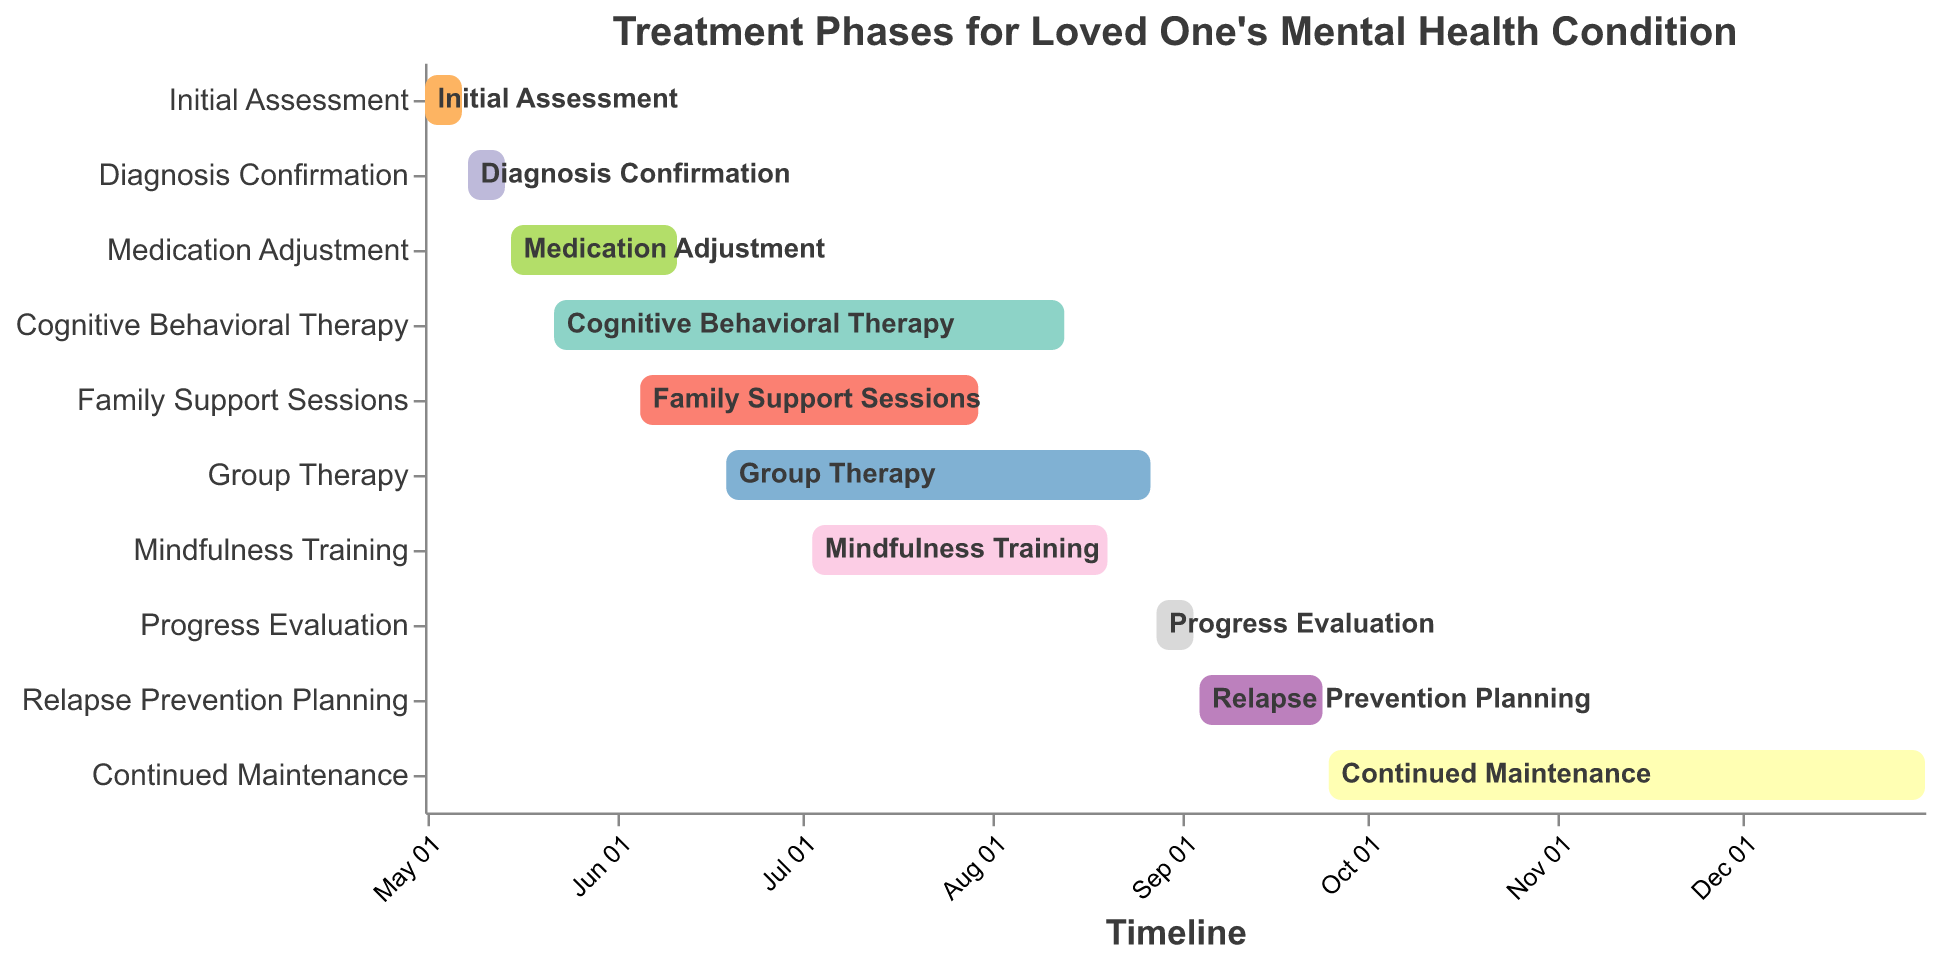What is the title of the figure? The title of the figure is shown at the top of the chart.
Answer: Treatment Phases for Loved One's Mental Health Condition Which treatment phase starts on July 3, 2023? Refer to the x-axis for the dates and find the task corresponding to July 3, 2023.
Answer: Mindfulness Training How long does the Medication Adjustment phase last? Look at the start and end dates for Medication Adjustment; from May 15, 2023, to June 11, 2023. Calculate the number of days between these dates.
Answer: 27 days Which two treatment phases overlap the most? By comparing the start and end dates of each task visually, identify that Cognitive Behavioral Therapy (May 22 to August 13) and Medication Adjustment (May 15 to June 11) have overlapping periods.
Answer: Cognitive Behavioral Therapy and Medication Adjustment What treatment phase is scheduled to end on December 31, 2023? Check the end dates for all tasks and find the task that ends on December 31, 2023.
Answer: Continued Maintenance Which phase starts immediately after the Cognitive Behavioral Therapy phase ends? Find the end date for Cognitive Behavioral Therapy, which is August 13, 2023, then locate the task starting immediately after.
Answer: Progress Evaluation How many treatment phases start in May 2023? Count the number of tasks with start dates in May 2023.
Answer: 3 Which phase lasts the longest, and how many days does it span? Compare the durations of all tasks by calculating the difference between start and end dates, identifying that Continued Maintenance is the longest.
Answer: Continued Maintenance, 99 days How much time is there between the end of Mindfulness Training and the start of Relapse Prevention Planning? Find the end of Mindfulness Training (August 20, 2023), and the start of Relapse Prevention Planning (September 4, 2023), then calculate the number of days between these dates.
Answer: 15 days Which treatment phases are conducted simultaneously for at least one day? Look for overlapping dates among the phases; Initial Assessment and Diagnosis Confirmation; Medication Adjustment and Cognitive Behavioral Therapy; Family Support Sessions, Group Therapy, and Mindfulness Training all have days that coincide.
Answer: Multiple phases overlap 